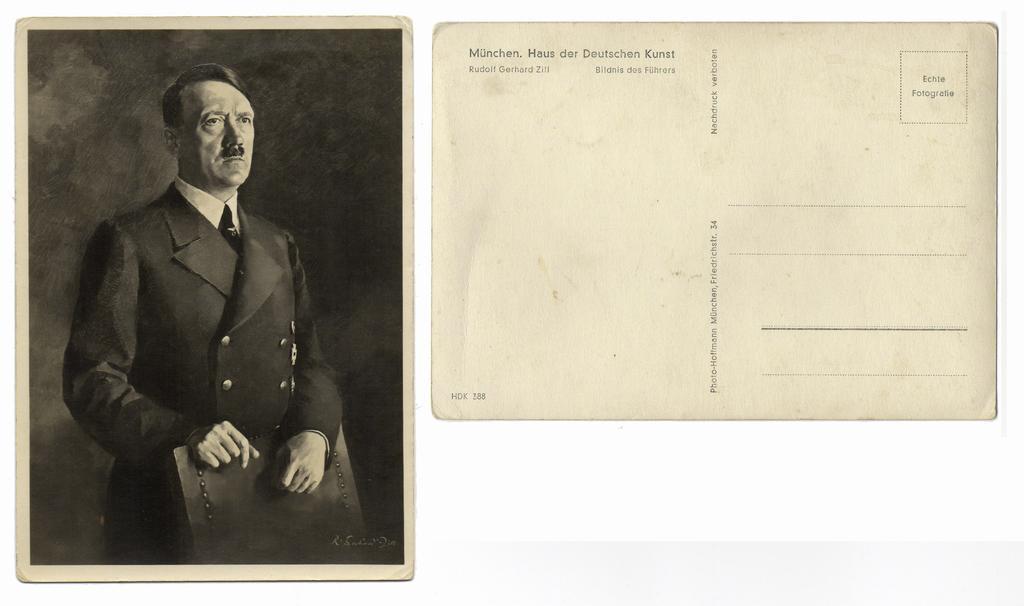Describe this image in one or two sentences. This picture is a black and white image. In this image we can see two photos, one photo with text on the right side of the image, one photo with a man in a suit standing and holding a chair on the left side of the image. The background is dark on the left side of the image photo. 